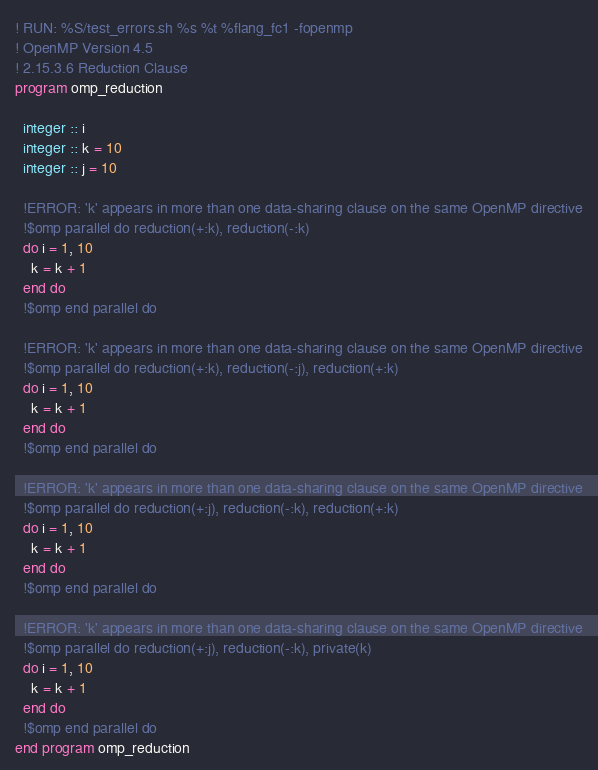Convert code to text. <code><loc_0><loc_0><loc_500><loc_500><_FORTRAN_>! RUN: %S/test_errors.sh %s %t %flang_fc1 -fopenmp
! OpenMP Version 4.5
! 2.15.3.6 Reduction Clause
program omp_reduction

  integer :: i
  integer :: k = 10
  integer :: j = 10

  !ERROR: 'k' appears in more than one data-sharing clause on the same OpenMP directive
  !$omp parallel do reduction(+:k), reduction(-:k)
  do i = 1, 10
    k = k + 1
  end do
  !$omp end parallel do

  !ERROR: 'k' appears in more than one data-sharing clause on the same OpenMP directive
  !$omp parallel do reduction(+:k), reduction(-:j), reduction(+:k)
  do i = 1, 10
    k = k + 1
  end do
  !$omp end parallel do

  !ERROR: 'k' appears in more than one data-sharing clause on the same OpenMP directive
  !$omp parallel do reduction(+:j), reduction(-:k), reduction(+:k)
  do i = 1, 10
    k = k + 1
  end do
  !$omp end parallel do

  !ERROR: 'k' appears in more than one data-sharing clause on the same OpenMP directive
  !$omp parallel do reduction(+:j), reduction(-:k), private(k)
  do i = 1, 10
    k = k + 1
  end do
  !$omp end parallel do
end program omp_reduction
</code> 